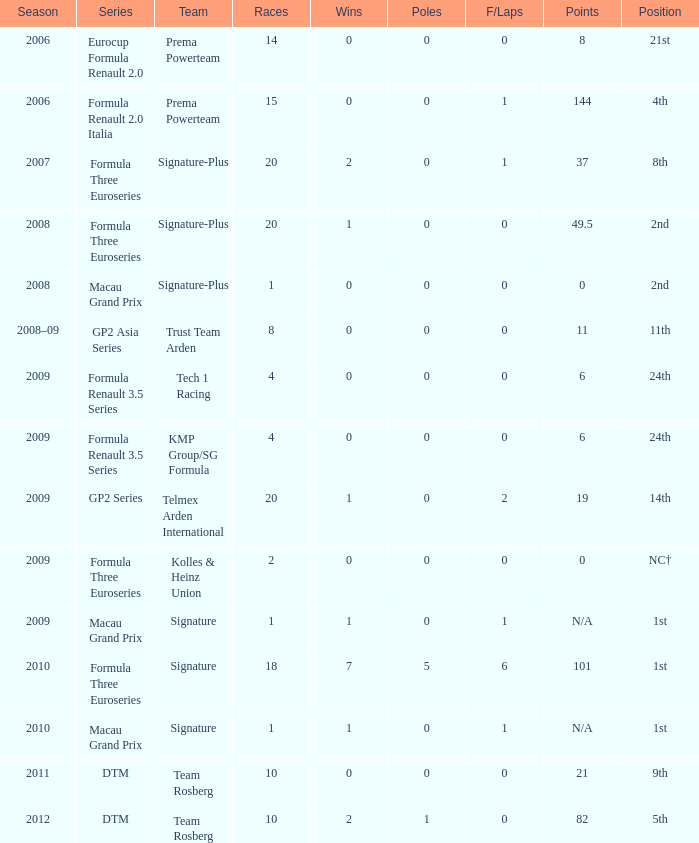Which series has 11 points? GP2 Asia Series. 